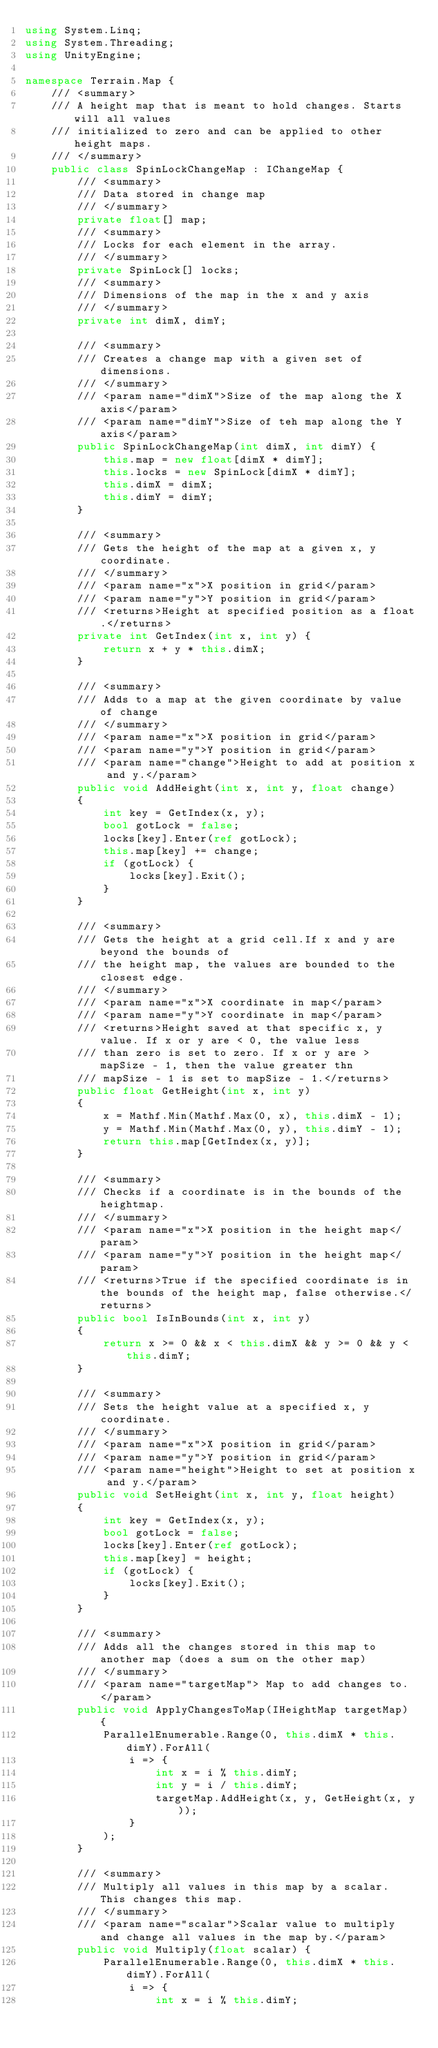<code> <loc_0><loc_0><loc_500><loc_500><_C#_>using System.Linq;
using System.Threading;
using UnityEngine;

namespace Terrain.Map {
    /// <summary>
    /// A height map that is meant to hold changes. Starts will all values
    /// initialized to zero and can be applied to other height maps.
    /// </summary>
    public class SpinLockChangeMap : IChangeMap {
        /// <summary>
        /// Data stored in change map
        /// </summary>
        private float[] map;
        /// <summary>
        /// Locks for each element in the array.
        /// </summary>
        private SpinLock[] locks;
        /// <summary>
        /// Dimensions of the map in the x and y axis
        /// </summary>
        private int dimX, dimY;

        /// <summary>
        /// Creates a change map with a given set of dimensions.
        /// </summary>
        /// <param name="dimX">Size of the map along the X axis</param>
        /// <param name="dimY">Size of teh map along the Y axis</param>
        public SpinLockChangeMap(int dimX, int dimY) {
            this.map = new float[dimX * dimY];
            this.locks = new SpinLock[dimX * dimY];
            this.dimX = dimX;
            this.dimY = dimY;
        }
        
        /// <summary>
        /// Gets the height of the map at a given x, y coordinate.
        /// </summary>
        /// <param name="x">X position in grid</param>
        /// <param name="y">Y position in grid</param>
        /// <returns>Height at specified position as a float.</returns>
        private int GetIndex(int x, int y) {
            return x + y * this.dimX;
        }

        /// <summary>
        /// Adds to a map at the given coordinate by value of change
        /// </summary>
        /// <param name="x">X position in grid</param>
        /// <param name="y">Y position in grid</param>
        /// <param name="change">Height to add at position x and y.</param>
        public void AddHeight(int x, int y, float change)
        {
            int key = GetIndex(x, y);
            bool gotLock = false;
            locks[key].Enter(ref gotLock);
            this.map[key] += change;
            if (gotLock) {
                locks[key].Exit();
            }
        }

        /// <summary>
        /// Gets the height at a grid cell.If x and y are beyond the bounds of 
        /// the height map, the values are bounded to the closest edge.
        /// </summary>
        /// <param name="x">X coordinate in map</param>
        /// <param name="y">Y coordinate in map</param>
        /// <returns>Height saved at that specific x, y value. If x or y are < 0, the value less
        /// than zero is set to zero. If x or y are > mapSize - 1, then the value greater thn
        /// mapSize - 1 is set to mapSize - 1.</returns>
        public float GetHeight(int x, int y)
        {
            x = Mathf.Min(Mathf.Max(0, x), this.dimX - 1);
            y = Mathf.Min(Mathf.Max(0, y), this.dimY - 1);
            return this.map[GetIndex(x, y)];
        }

        /// <summary>
        /// Checks if a coordinate is in the bounds of the heightmap.
        /// </summary>
        /// <param name="x">X position in the height map</param>
        /// <param name="y">Y position in the height map</param>
        /// <returns>True if the specified coordinate is in the bounds of the height map, false otherwise.</returns>
        public bool IsInBounds(int x, int y)
        {
            return x >= 0 && x < this.dimX && y >= 0 && y < this.dimY;
        }

        /// <summary>
        /// Sets the height value at a specified x, y coordinate.
        /// </summary>
        /// <param name="x">X position in grid</param>
        /// <param name="y">Y position in grid</param>
        /// <param name="height">Height to set at position x and y.</param>
        public void SetHeight(int x, int y, float height)
        {
            int key = GetIndex(x, y);
            bool gotLock = false;
            locks[key].Enter(ref gotLock);
            this.map[key] = height;
            if (gotLock) {
                locks[key].Exit();
            }
        }

        /// <summary>
        /// Adds all the changes stored in this map to another map (does a sum on the other map)
        /// </summary>
        /// <param name="targetMap"> Map to add changes to. </param>
        public void ApplyChangesToMap(IHeightMap targetMap) {
            ParallelEnumerable.Range(0, this.dimX * this.dimY).ForAll(
                i => {
                    int x = i % this.dimY;
                    int y = i / this.dimY;
                    targetMap.AddHeight(x, y, GetHeight(x, y));
                }
            );
        }

        /// <summary>
        /// Multiply all values in this map by a scalar. This changes this map.
        /// </summary>
        /// <param name="scalar">Scalar value to multiply and change all values in the map by.</param>
        public void Multiply(float scalar) {
            ParallelEnumerable.Range(0, this.dimX * this.dimY).ForAll(
                i => {
                    int x = i % this.dimY;</code> 